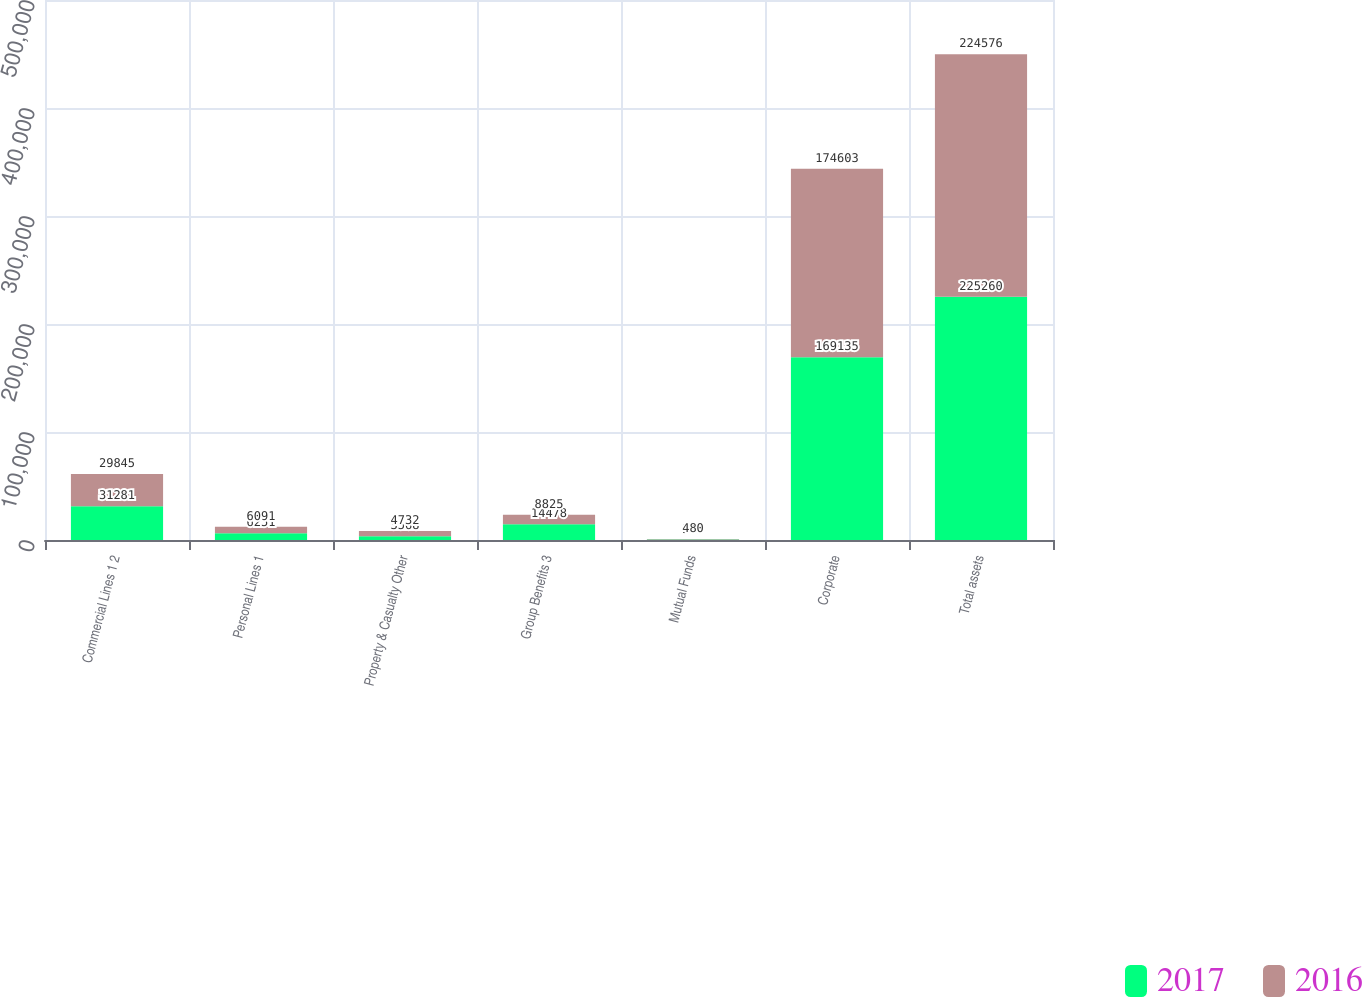Convert chart. <chart><loc_0><loc_0><loc_500><loc_500><stacked_bar_chart><ecel><fcel>Commercial Lines 1 2<fcel>Personal Lines 1<fcel>Property & Casualty Other<fcel>Group Benefits 3<fcel>Mutual Funds<fcel>Corporate<fcel>Total assets<nl><fcel>2017<fcel>31281<fcel>6251<fcel>3568<fcel>14478<fcel>547<fcel>169135<fcel>225260<nl><fcel>2016<fcel>29845<fcel>6091<fcel>4732<fcel>8825<fcel>480<fcel>174603<fcel>224576<nl></chart> 